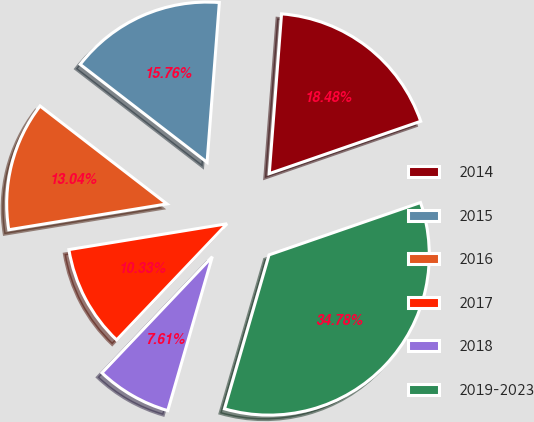Convert chart to OTSL. <chart><loc_0><loc_0><loc_500><loc_500><pie_chart><fcel>2014<fcel>2015<fcel>2016<fcel>2017<fcel>2018<fcel>2019-2023<nl><fcel>18.48%<fcel>15.76%<fcel>13.04%<fcel>10.33%<fcel>7.61%<fcel>34.78%<nl></chart> 